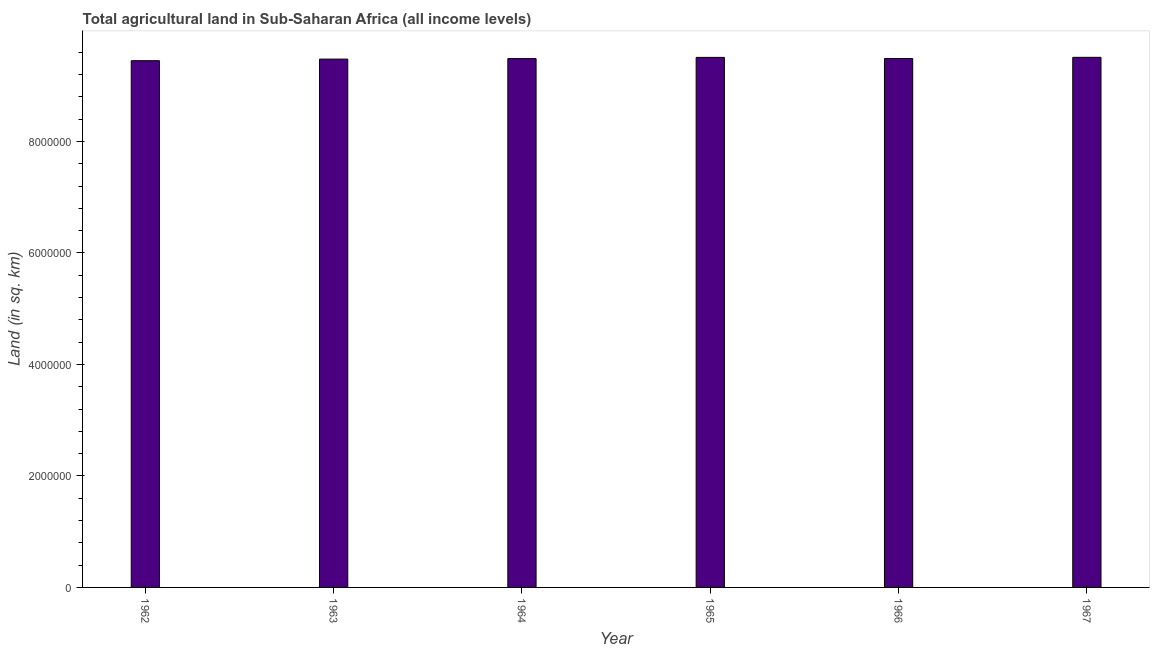Does the graph contain any zero values?
Provide a succinct answer. No. What is the title of the graph?
Your answer should be compact. Total agricultural land in Sub-Saharan Africa (all income levels). What is the label or title of the X-axis?
Keep it short and to the point. Year. What is the label or title of the Y-axis?
Your answer should be very brief. Land (in sq. km). What is the agricultural land in 1963?
Your response must be concise. 9.48e+06. Across all years, what is the maximum agricultural land?
Offer a very short reply. 9.51e+06. Across all years, what is the minimum agricultural land?
Keep it short and to the point. 9.45e+06. In which year was the agricultural land maximum?
Your answer should be very brief. 1967. In which year was the agricultural land minimum?
Keep it short and to the point. 1962. What is the sum of the agricultural land?
Give a very brief answer. 5.69e+07. What is the difference between the agricultural land in 1966 and 1967?
Offer a terse response. -2.18e+04. What is the average agricultural land per year?
Give a very brief answer. 9.49e+06. What is the median agricultural land?
Your response must be concise. 9.49e+06. In how many years, is the agricultural land greater than 8000000 sq. km?
Your answer should be compact. 6. Do a majority of the years between 1964 and 1963 (inclusive) have agricultural land greater than 400000 sq. km?
Keep it short and to the point. No. What is the ratio of the agricultural land in 1963 to that in 1964?
Ensure brevity in your answer.  1. Is the agricultural land in 1965 less than that in 1966?
Your response must be concise. No. Is the difference between the agricultural land in 1963 and 1966 greater than the difference between any two years?
Keep it short and to the point. No. What is the difference between the highest and the second highest agricultural land?
Offer a very short reply. 1287.4. Is the sum of the agricultural land in 1962 and 1963 greater than the maximum agricultural land across all years?
Offer a terse response. Yes. What is the difference between the highest and the lowest agricultural land?
Provide a succinct answer. 6.02e+04. How many bars are there?
Provide a succinct answer. 6. How many years are there in the graph?
Keep it short and to the point. 6. What is the difference between two consecutive major ticks on the Y-axis?
Provide a short and direct response. 2.00e+06. Are the values on the major ticks of Y-axis written in scientific E-notation?
Ensure brevity in your answer.  No. What is the Land (in sq. km) of 1962?
Your answer should be very brief. 9.45e+06. What is the Land (in sq. km) of 1963?
Keep it short and to the point. 9.48e+06. What is the Land (in sq. km) of 1964?
Offer a very short reply. 9.49e+06. What is the Land (in sq. km) in 1965?
Provide a succinct answer. 9.51e+06. What is the Land (in sq. km) in 1966?
Your response must be concise. 9.49e+06. What is the Land (in sq. km) of 1967?
Keep it short and to the point. 9.51e+06. What is the difference between the Land (in sq. km) in 1962 and 1963?
Your answer should be compact. -2.85e+04. What is the difference between the Land (in sq. km) in 1962 and 1964?
Make the answer very short. -3.74e+04. What is the difference between the Land (in sq. km) in 1962 and 1965?
Provide a succinct answer. -5.90e+04. What is the difference between the Land (in sq. km) in 1962 and 1966?
Keep it short and to the point. -3.85e+04. What is the difference between the Land (in sq. km) in 1962 and 1967?
Provide a short and direct response. -6.02e+04. What is the difference between the Land (in sq. km) in 1963 and 1964?
Offer a terse response. -8941.6. What is the difference between the Land (in sq. km) in 1963 and 1965?
Keep it short and to the point. -3.05e+04. What is the difference between the Land (in sq. km) in 1963 and 1966?
Provide a succinct answer. -1.00e+04. What is the difference between the Land (in sq. km) in 1963 and 1967?
Ensure brevity in your answer.  -3.18e+04. What is the difference between the Land (in sq. km) in 1964 and 1965?
Provide a short and direct response. -2.16e+04. What is the difference between the Land (in sq. km) in 1964 and 1966?
Offer a very short reply. -1059.2. What is the difference between the Land (in sq. km) in 1964 and 1967?
Your answer should be compact. -2.28e+04. What is the difference between the Land (in sq. km) in 1965 and 1966?
Make the answer very short. 2.05e+04. What is the difference between the Land (in sq. km) in 1965 and 1967?
Offer a very short reply. -1287.4. What is the difference between the Land (in sq. km) in 1966 and 1967?
Offer a very short reply. -2.18e+04. What is the ratio of the Land (in sq. km) in 1962 to that in 1966?
Keep it short and to the point. 1. What is the ratio of the Land (in sq. km) in 1963 to that in 1965?
Provide a succinct answer. 1. What is the ratio of the Land (in sq. km) in 1964 to that in 1966?
Keep it short and to the point. 1. What is the ratio of the Land (in sq. km) in 1965 to that in 1966?
Offer a very short reply. 1. What is the ratio of the Land (in sq. km) in 1966 to that in 1967?
Give a very brief answer. 1. 